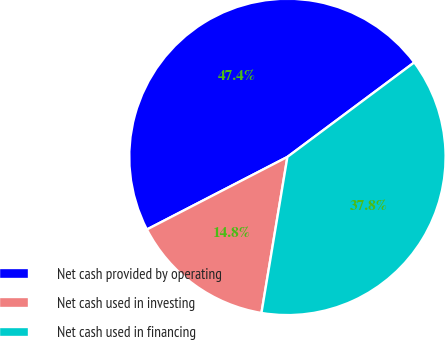Convert chart. <chart><loc_0><loc_0><loc_500><loc_500><pie_chart><fcel>Net cash provided by operating<fcel>Net cash used in investing<fcel>Net cash used in financing<nl><fcel>47.4%<fcel>14.79%<fcel>37.82%<nl></chart> 